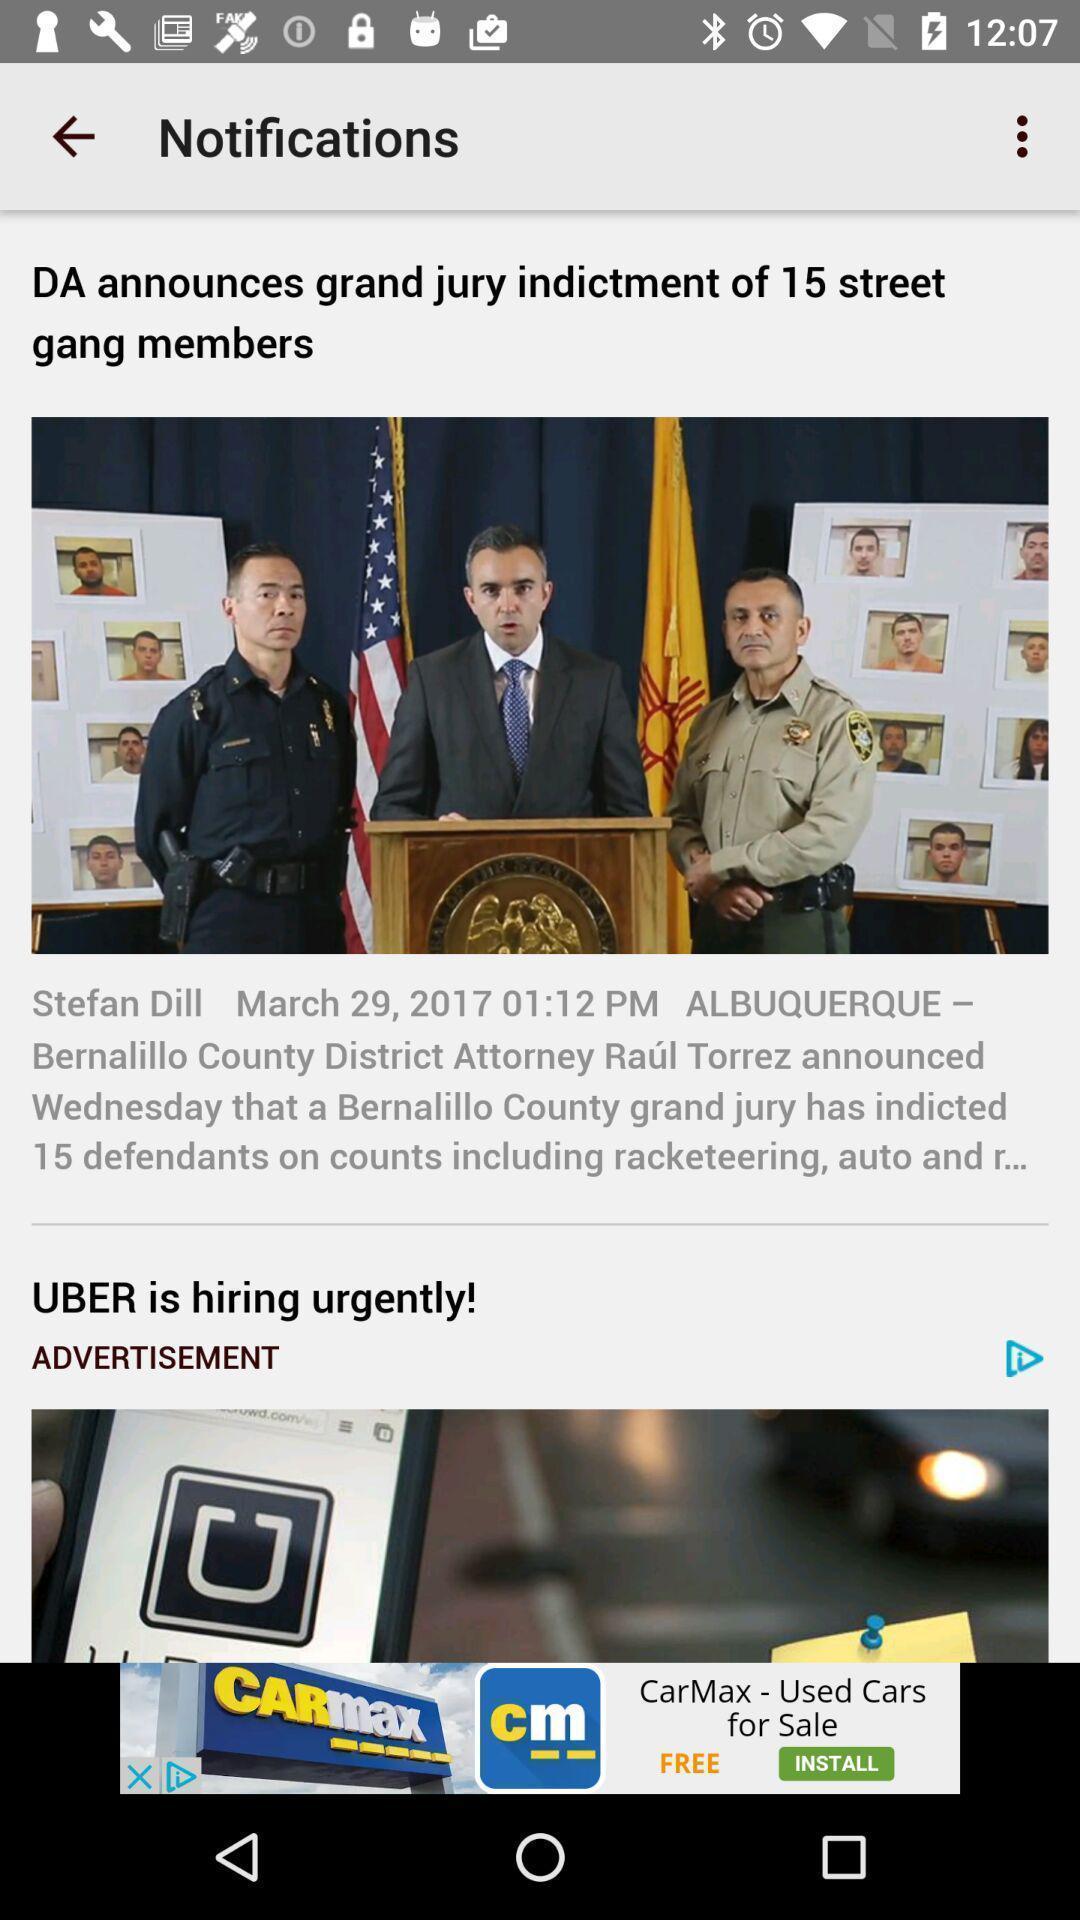Explain what's happening in this screen capture. Page shows the notifications. 